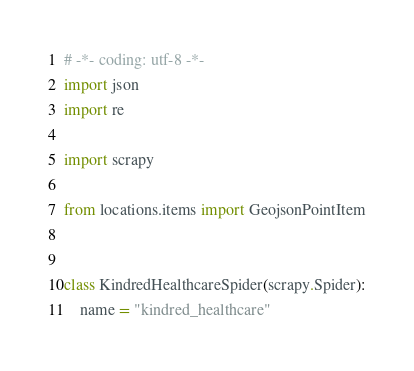<code> <loc_0><loc_0><loc_500><loc_500><_Python_># -*- coding: utf-8 -*-
import json
import re

import scrapy

from locations.items import GeojsonPointItem


class KindredHealthcareSpider(scrapy.Spider):
    name = "kindred_healthcare"</code> 